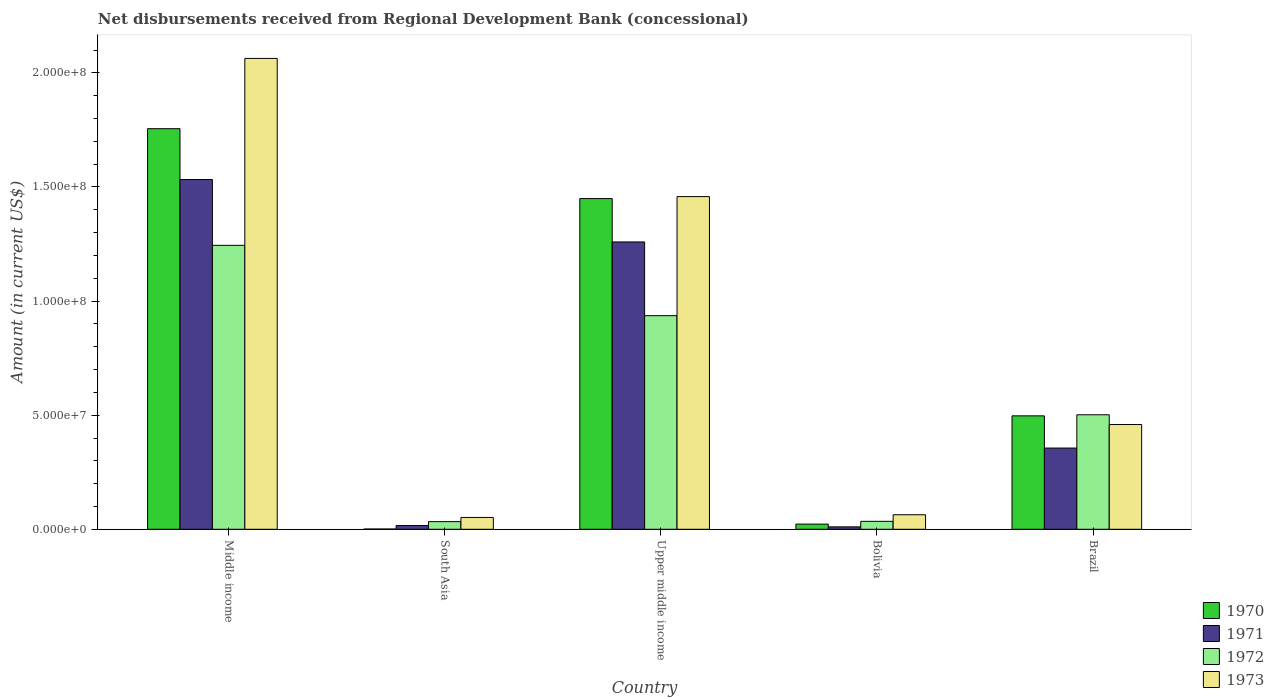How many different coloured bars are there?
Your answer should be very brief. 4. How many groups of bars are there?
Provide a short and direct response. 5. Are the number of bars per tick equal to the number of legend labels?
Offer a terse response. Yes. How many bars are there on the 4th tick from the right?
Your answer should be compact. 4. What is the label of the 5th group of bars from the left?
Provide a succinct answer. Brazil. In how many cases, is the number of bars for a given country not equal to the number of legend labels?
Offer a very short reply. 0. What is the amount of disbursements received from Regional Development Bank in 1973 in Brazil?
Give a very brief answer. 4.59e+07. Across all countries, what is the maximum amount of disbursements received from Regional Development Bank in 1973?
Ensure brevity in your answer.  2.06e+08. Across all countries, what is the minimum amount of disbursements received from Regional Development Bank in 1973?
Your answer should be very brief. 5.18e+06. In which country was the amount of disbursements received from Regional Development Bank in 1970 maximum?
Your answer should be very brief. Middle income. What is the total amount of disbursements received from Regional Development Bank in 1970 in the graph?
Your response must be concise. 3.73e+08. What is the difference between the amount of disbursements received from Regional Development Bank in 1971 in Bolivia and that in Brazil?
Provide a succinct answer. -3.45e+07. What is the difference between the amount of disbursements received from Regional Development Bank in 1973 in Middle income and the amount of disbursements received from Regional Development Bank in 1971 in Bolivia?
Your response must be concise. 2.05e+08. What is the average amount of disbursements received from Regional Development Bank in 1972 per country?
Offer a terse response. 5.50e+07. What is the difference between the amount of disbursements received from Regional Development Bank of/in 1973 and amount of disbursements received from Regional Development Bank of/in 1970 in South Asia?
Keep it short and to the point. 5.08e+06. What is the ratio of the amount of disbursements received from Regional Development Bank in 1973 in Brazil to that in Middle income?
Provide a succinct answer. 0.22. Is the amount of disbursements received from Regional Development Bank in 1973 in Brazil less than that in South Asia?
Offer a very short reply. No. Is the difference between the amount of disbursements received from Regional Development Bank in 1973 in South Asia and Upper middle income greater than the difference between the amount of disbursements received from Regional Development Bank in 1970 in South Asia and Upper middle income?
Offer a very short reply. Yes. What is the difference between the highest and the second highest amount of disbursements received from Regional Development Bank in 1971?
Provide a short and direct response. 1.18e+08. What is the difference between the highest and the lowest amount of disbursements received from Regional Development Bank in 1971?
Ensure brevity in your answer.  1.52e+08. In how many countries, is the amount of disbursements received from Regional Development Bank in 1972 greater than the average amount of disbursements received from Regional Development Bank in 1972 taken over all countries?
Provide a succinct answer. 2. Is the sum of the amount of disbursements received from Regional Development Bank in 1970 in Bolivia and Middle income greater than the maximum amount of disbursements received from Regional Development Bank in 1973 across all countries?
Provide a short and direct response. No. Is it the case that in every country, the sum of the amount of disbursements received from Regional Development Bank in 1973 and amount of disbursements received from Regional Development Bank in 1972 is greater than the sum of amount of disbursements received from Regional Development Bank in 1970 and amount of disbursements received from Regional Development Bank in 1971?
Provide a succinct answer. No. What does the 2nd bar from the right in Bolivia represents?
Give a very brief answer. 1972. Is it the case that in every country, the sum of the amount of disbursements received from Regional Development Bank in 1971 and amount of disbursements received from Regional Development Bank in 1972 is greater than the amount of disbursements received from Regional Development Bank in 1973?
Give a very brief answer. No. How many bars are there?
Provide a succinct answer. 20. Are all the bars in the graph horizontal?
Provide a succinct answer. No. What is the difference between two consecutive major ticks on the Y-axis?
Offer a terse response. 5.00e+07. Are the values on the major ticks of Y-axis written in scientific E-notation?
Provide a short and direct response. Yes. Does the graph contain grids?
Your response must be concise. No. How many legend labels are there?
Make the answer very short. 4. What is the title of the graph?
Your answer should be compact. Net disbursements received from Regional Development Bank (concessional). Does "1982" appear as one of the legend labels in the graph?
Your response must be concise. No. What is the label or title of the Y-axis?
Give a very brief answer. Amount (in current US$). What is the Amount (in current US$) of 1970 in Middle income?
Offer a very short reply. 1.76e+08. What is the Amount (in current US$) of 1971 in Middle income?
Offer a terse response. 1.53e+08. What is the Amount (in current US$) in 1972 in Middle income?
Provide a succinct answer. 1.24e+08. What is the Amount (in current US$) in 1973 in Middle income?
Give a very brief answer. 2.06e+08. What is the Amount (in current US$) in 1970 in South Asia?
Ensure brevity in your answer.  1.09e+05. What is the Amount (in current US$) of 1971 in South Asia?
Give a very brief answer. 1.65e+06. What is the Amount (in current US$) in 1972 in South Asia?
Offer a terse response. 3.35e+06. What is the Amount (in current US$) of 1973 in South Asia?
Offer a very short reply. 5.18e+06. What is the Amount (in current US$) of 1970 in Upper middle income?
Provide a succinct answer. 1.45e+08. What is the Amount (in current US$) of 1971 in Upper middle income?
Offer a very short reply. 1.26e+08. What is the Amount (in current US$) of 1972 in Upper middle income?
Offer a terse response. 9.36e+07. What is the Amount (in current US$) in 1973 in Upper middle income?
Ensure brevity in your answer.  1.46e+08. What is the Amount (in current US$) of 1970 in Bolivia?
Keep it short and to the point. 2.27e+06. What is the Amount (in current US$) in 1971 in Bolivia?
Ensure brevity in your answer.  1.06e+06. What is the Amount (in current US$) of 1972 in Bolivia?
Keep it short and to the point. 3.48e+06. What is the Amount (in current US$) of 1973 in Bolivia?
Your response must be concise. 6.36e+06. What is the Amount (in current US$) of 1970 in Brazil?
Ensure brevity in your answer.  4.97e+07. What is the Amount (in current US$) in 1971 in Brazil?
Your response must be concise. 3.56e+07. What is the Amount (in current US$) in 1972 in Brazil?
Offer a very short reply. 5.02e+07. What is the Amount (in current US$) of 1973 in Brazil?
Your response must be concise. 4.59e+07. Across all countries, what is the maximum Amount (in current US$) of 1970?
Offer a very short reply. 1.76e+08. Across all countries, what is the maximum Amount (in current US$) of 1971?
Offer a very short reply. 1.53e+08. Across all countries, what is the maximum Amount (in current US$) of 1972?
Your answer should be very brief. 1.24e+08. Across all countries, what is the maximum Amount (in current US$) in 1973?
Offer a terse response. 2.06e+08. Across all countries, what is the minimum Amount (in current US$) of 1970?
Provide a short and direct response. 1.09e+05. Across all countries, what is the minimum Amount (in current US$) of 1971?
Provide a short and direct response. 1.06e+06. Across all countries, what is the minimum Amount (in current US$) in 1972?
Provide a short and direct response. 3.35e+06. Across all countries, what is the minimum Amount (in current US$) of 1973?
Provide a succinct answer. 5.18e+06. What is the total Amount (in current US$) of 1970 in the graph?
Provide a short and direct response. 3.73e+08. What is the total Amount (in current US$) in 1971 in the graph?
Your answer should be very brief. 3.17e+08. What is the total Amount (in current US$) of 1972 in the graph?
Keep it short and to the point. 2.75e+08. What is the total Amount (in current US$) of 1973 in the graph?
Give a very brief answer. 4.10e+08. What is the difference between the Amount (in current US$) of 1970 in Middle income and that in South Asia?
Your answer should be very brief. 1.75e+08. What is the difference between the Amount (in current US$) in 1971 in Middle income and that in South Asia?
Offer a terse response. 1.52e+08. What is the difference between the Amount (in current US$) of 1972 in Middle income and that in South Asia?
Your answer should be compact. 1.21e+08. What is the difference between the Amount (in current US$) in 1973 in Middle income and that in South Asia?
Ensure brevity in your answer.  2.01e+08. What is the difference between the Amount (in current US$) of 1970 in Middle income and that in Upper middle income?
Offer a very short reply. 3.06e+07. What is the difference between the Amount (in current US$) in 1971 in Middle income and that in Upper middle income?
Your response must be concise. 2.74e+07. What is the difference between the Amount (in current US$) in 1972 in Middle income and that in Upper middle income?
Your answer should be very brief. 3.08e+07. What is the difference between the Amount (in current US$) of 1973 in Middle income and that in Upper middle income?
Offer a very short reply. 6.06e+07. What is the difference between the Amount (in current US$) in 1970 in Middle income and that in Bolivia?
Your answer should be very brief. 1.73e+08. What is the difference between the Amount (in current US$) of 1971 in Middle income and that in Bolivia?
Offer a very short reply. 1.52e+08. What is the difference between the Amount (in current US$) in 1972 in Middle income and that in Bolivia?
Make the answer very short. 1.21e+08. What is the difference between the Amount (in current US$) in 1973 in Middle income and that in Bolivia?
Your answer should be compact. 2.00e+08. What is the difference between the Amount (in current US$) of 1970 in Middle income and that in Brazil?
Your answer should be very brief. 1.26e+08. What is the difference between the Amount (in current US$) of 1971 in Middle income and that in Brazil?
Ensure brevity in your answer.  1.18e+08. What is the difference between the Amount (in current US$) of 1972 in Middle income and that in Brazil?
Provide a short and direct response. 7.43e+07. What is the difference between the Amount (in current US$) in 1973 in Middle income and that in Brazil?
Offer a very short reply. 1.60e+08. What is the difference between the Amount (in current US$) of 1970 in South Asia and that in Upper middle income?
Ensure brevity in your answer.  -1.45e+08. What is the difference between the Amount (in current US$) of 1971 in South Asia and that in Upper middle income?
Give a very brief answer. -1.24e+08. What is the difference between the Amount (in current US$) of 1972 in South Asia and that in Upper middle income?
Provide a short and direct response. -9.03e+07. What is the difference between the Amount (in current US$) of 1973 in South Asia and that in Upper middle income?
Your answer should be compact. -1.41e+08. What is the difference between the Amount (in current US$) in 1970 in South Asia and that in Bolivia?
Your answer should be very brief. -2.16e+06. What is the difference between the Amount (in current US$) of 1971 in South Asia and that in Bolivia?
Provide a succinct answer. 5.92e+05. What is the difference between the Amount (in current US$) of 1972 in South Asia and that in Bolivia?
Make the answer very short. -1.30e+05. What is the difference between the Amount (in current US$) in 1973 in South Asia and that in Bolivia?
Ensure brevity in your answer.  -1.18e+06. What is the difference between the Amount (in current US$) in 1970 in South Asia and that in Brazil?
Provide a succinct answer. -4.96e+07. What is the difference between the Amount (in current US$) of 1971 in South Asia and that in Brazil?
Offer a very short reply. -3.39e+07. What is the difference between the Amount (in current US$) of 1972 in South Asia and that in Brazil?
Your response must be concise. -4.68e+07. What is the difference between the Amount (in current US$) in 1973 in South Asia and that in Brazil?
Your response must be concise. -4.07e+07. What is the difference between the Amount (in current US$) in 1970 in Upper middle income and that in Bolivia?
Keep it short and to the point. 1.43e+08. What is the difference between the Amount (in current US$) of 1971 in Upper middle income and that in Bolivia?
Your answer should be very brief. 1.25e+08. What is the difference between the Amount (in current US$) of 1972 in Upper middle income and that in Bolivia?
Offer a very short reply. 9.01e+07. What is the difference between the Amount (in current US$) in 1973 in Upper middle income and that in Bolivia?
Your answer should be compact. 1.39e+08. What is the difference between the Amount (in current US$) in 1970 in Upper middle income and that in Brazil?
Ensure brevity in your answer.  9.52e+07. What is the difference between the Amount (in current US$) of 1971 in Upper middle income and that in Brazil?
Give a very brief answer. 9.03e+07. What is the difference between the Amount (in current US$) of 1972 in Upper middle income and that in Brazil?
Make the answer very short. 4.34e+07. What is the difference between the Amount (in current US$) in 1973 in Upper middle income and that in Brazil?
Offer a terse response. 9.99e+07. What is the difference between the Amount (in current US$) in 1970 in Bolivia and that in Brazil?
Your answer should be compact. -4.74e+07. What is the difference between the Amount (in current US$) in 1971 in Bolivia and that in Brazil?
Offer a very short reply. -3.45e+07. What is the difference between the Amount (in current US$) of 1972 in Bolivia and that in Brazil?
Keep it short and to the point. -4.67e+07. What is the difference between the Amount (in current US$) of 1973 in Bolivia and that in Brazil?
Ensure brevity in your answer.  -3.95e+07. What is the difference between the Amount (in current US$) in 1970 in Middle income and the Amount (in current US$) in 1971 in South Asia?
Provide a succinct answer. 1.74e+08. What is the difference between the Amount (in current US$) in 1970 in Middle income and the Amount (in current US$) in 1972 in South Asia?
Your answer should be very brief. 1.72e+08. What is the difference between the Amount (in current US$) in 1970 in Middle income and the Amount (in current US$) in 1973 in South Asia?
Keep it short and to the point. 1.70e+08. What is the difference between the Amount (in current US$) in 1971 in Middle income and the Amount (in current US$) in 1972 in South Asia?
Your answer should be compact. 1.50e+08. What is the difference between the Amount (in current US$) of 1971 in Middle income and the Amount (in current US$) of 1973 in South Asia?
Offer a very short reply. 1.48e+08. What is the difference between the Amount (in current US$) of 1972 in Middle income and the Amount (in current US$) of 1973 in South Asia?
Provide a short and direct response. 1.19e+08. What is the difference between the Amount (in current US$) in 1970 in Middle income and the Amount (in current US$) in 1971 in Upper middle income?
Offer a terse response. 4.96e+07. What is the difference between the Amount (in current US$) in 1970 in Middle income and the Amount (in current US$) in 1972 in Upper middle income?
Keep it short and to the point. 8.19e+07. What is the difference between the Amount (in current US$) of 1970 in Middle income and the Amount (in current US$) of 1973 in Upper middle income?
Offer a very short reply. 2.98e+07. What is the difference between the Amount (in current US$) of 1971 in Middle income and the Amount (in current US$) of 1972 in Upper middle income?
Ensure brevity in your answer.  5.97e+07. What is the difference between the Amount (in current US$) in 1971 in Middle income and the Amount (in current US$) in 1973 in Upper middle income?
Give a very brief answer. 7.49e+06. What is the difference between the Amount (in current US$) in 1972 in Middle income and the Amount (in current US$) in 1973 in Upper middle income?
Provide a short and direct response. -2.14e+07. What is the difference between the Amount (in current US$) of 1970 in Middle income and the Amount (in current US$) of 1971 in Bolivia?
Provide a short and direct response. 1.74e+08. What is the difference between the Amount (in current US$) of 1970 in Middle income and the Amount (in current US$) of 1972 in Bolivia?
Provide a short and direct response. 1.72e+08. What is the difference between the Amount (in current US$) in 1970 in Middle income and the Amount (in current US$) in 1973 in Bolivia?
Ensure brevity in your answer.  1.69e+08. What is the difference between the Amount (in current US$) of 1971 in Middle income and the Amount (in current US$) of 1972 in Bolivia?
Provide a short and direct response. 1.50e+08. What is the difference between the Amount (in current US$) of 1971 in Middle income and the Amount (in current US$) of 1973 in Bolivia?
Provide a succinct answer. 1.47e+08. What is the difference between the Amount (in current US$) of 1972 in Middle income and the Amount (in current US$) of 1973 in Bolivia?
Provide a succinct answer. 1.18e+08. What is the difference between the Amount (in current US$) of 1970 in Middle income and the Amount (in current US$) of 1971 in Brazil?
Provide a short and direct response. 1.40e+08. What is the difference between the Amount (in current US$) of 1970 in Middle income and the Amount (in current US$) of 1972 in Brazil?
Keep it short and to the point. 1.25e+08. What is the difference between the Amount (in current US$) of 1970 in Middle income and the Amount (in current US$) of 1973 in Brazil?
Make the answer very short. 1.30e+08. What is the difference between the Amount (in current US$) in 1971 in Middle income and the Amount (in current US$) in 1972 in Brazil?
Offer a very short reply. 1.03e+08. What is the difference between the Amount (in current US$) in 1971 in Middle income and the Amount (in current US$) in 1973 in Brazil?
Ensure brevity in your answer.  1.07e+08. What is the difference between the Amount (in current US$) in 1972 in Middle income and the Amount (in current US$) in 1973 in Brazil?
Your response must be concise. 7.85e+07. What is the difference between the Amount (in current US$) in 1970 in South Asia and the Amount (in current US$) in 1971 in Upper middle income?
Your answer should be very brief. -1.26e+08. What is the difference between the Amount (in current US$) of 1970 in South Asia and the Amount (in current US$) of 1972 in Upper middle income?
Your answer should be very brief. -9.35e+07. What is the difference between the Amount (in current US$) in 1970 in South Asia and the Amount (in current US$) in 1973 in Upper middle income?
Your answer should be very brief. -1.46e+08. What is the difference between the Amount (in current US$) of 1971 in South Asia and the Amount (in current US$) of 1972 in Upper middle income?
Keep it short and to the point. -9.20e+07. What is the difference between the Amount (in current US$) of 1971 in South Asia and the Amount (in current US$) of 1973 in Upper middle income?
Your answer should be very brief. -1.44e+08. What is the difference between the Amount (in current US$) in 1972 in South Asia and the Amount (in current US$) in 1973 in Upper middle income?
Provide a short and direct response. -1.42e+08. What is the difference between the Amount (in current US$) in 1970 in South Asia and the Amount (in current US$) in 1971 in Bolivia?
Offer a terse response. -9.49e+05. What is the difference between the Amount (in current US$) of 1970 in South Asia and the Amount (in current US$) of 1972 in Bolivia?
Ensure brevity in your answer.  -3.37e+06. What is the difference between the Amount (in current US$) in 1970 in South Asia and the Amount (in current US$) in 1973 in Bolivia?
Ensure brevity in your answer.  -6.25e+06. What is the difference between the Amount (in current US$) of 1971 in South Asia and the Amount (in current US$) of 1972 in Bolivia?
Offer a terse response. -1.83e+06. What is the difference between the Amount (in current US$) of 1971 in South Asia and the Amount (in current US$) of 1973 in Bolivia?
Provide a short and direct response. -4.71e+06. What is the difference between the Amount (in current US$) of 1972 in South Asia and the Amount (in current US$) of 1973 in Bolivia?
Keep it short and to the point. -3.01e+06. What is the difference between the Amount (in current US$) of 1970 in South Asia and the Amount (in current US$) of 1971 in Brazil?
Provide a succinct answer. -3.55e+07. What is the difference between the Amount (in current US$) of 1970 in South Asia and the Amount (in current US$) of 1972 in Brazil?
Your answer should be compact. -5.01e+07. What is the difference between the Amount (in current US$) of 1970 in South Asia and the Amount (in current US$) of 1973 in Brazil?
Your response must be concise. -4.58e+07. What is the difference between the Amount (in current US$) of 1971 in South Asia and the Amount (in current US$) of 1972 in Brazil?
Your response must be concise. -4.85e+07. What is the difference between the Amount (in current US$) in 1971 in South Asia and the Amount (in current US$) in 1973 in Brazil?
Your answer should be compact. -4.43e+07. What is the difference between the Amount (in current US$) in 1972 in South Asia and the Amount (in current US$) in 1973 in Brazil?
Give a very brief answer. -4.26e+07. What is the difference between the Amount (in current US$) in 1970 in Upper middle income and the Amount (in current US$) in 1971 in Bolivia?
Provide a succinct answer. 1.44e+08. What is the difference between the Amount (in current US$) in 1970 in Upper middle income and the Amount (in current US$) in 1972 in Bolivia?
Your answer should be compact. 1.41e+08. What is the difference between the Amount (in current US$) in 1970 in Upper middle income and the Amount (in current US$) in 1973 in Bolivia?
Offer a very short reply. 1.39e+08. What is the difference between the Amount (in current US$) in 1971 in Upper middle income and the Amount (in current US$) in 1972 in Bolivia?
Provide a short and direct response. 1.22e+08. What is the difference between the Amount (in current US$) of 1971 in Upper middle income and the Amount (in current US$) of 1973 in Bolivia?
Provide a short and direct response. 1.20e+08. What is the difference between the Amount (in current US$) in 1972 in Upper middle income and the Amount (in current US$) in 1973 in Bolivia?
Ensure brevity in your answer.  8.72e+07. What is the difference between the Amount (in current US$) of 1970 in Upper middle income and the Amount (in current US$) of 1971 in Brazil?
Provide a succinct answer. 1.09e+08. What is the difference between the Amount (in current US$) of 1970 in Upper middle income and the Amount (in current US$) of 1972 in Brazil?
Provide a short and direct response. 9.48e+07. What is the difference between the Amount (in current US$) of 1970 in Upper middle income and the Amount (in current US$) of 1973 in Brazil?
Your response must be concise. 9.90e+07. What is the difference between the Amount (in current US$) in 1971 in Upper middle income and the Amount (in current US$) in 1972 in Brazil?
Your answer should be very brief. 7.57e+07. What is the difference between the Amount (in current US$) of 1971 in Upper middle income and the Amount (in current US$) of 1973 in Brazil?
Give a very brief answer. 8.00e+07. What is the difference between the Amount (in current US$) in 1972 in Upper middle income and the Amount (in current US$) in 1973 in Brazil?
Ensure brevity in your answer.  4.77e+07. What is the difference between the Amount (in current US$) in 1970 in Bolivia and the Amount (in current US$) in 1971 in Brazil?
Provide a succinct answer. -3.33e+07. What is the difference between the Amount (in current US$) of 1970 in Bolivia and the Amount (in current US$) of 1972 in Brazil?
Offer a terse response. -4.79e+07. What is the difference between the Amount (in current US$) of 1970 in Bolivia and the Amount (in current US$) of 1973 in Brazil?
Keep it short and to the point. -4.36e+07. What is the difference between the Amount (in current US$) of 1971 in Bolivia and the Amount (in current US$) of 1972 in Brazil?
Provide a succinct answer. -4.91e+07. What is the difference between the Amount (in current US$) of 1971 in Bolivia and the Amount (in current US$) of 1973 in Brazil?
Offer a very short reply. -4.49e+07. What is the difference between the Amount (in current US$) of 1972 in Bolivia and the Amount (in current US$) of 1973 in Brazil?
Your response must be concise. -4.24e+07. What is the average Amount (in current US$) in 1970 per country?
Offer a very short reply. 7.45e+07. What is the average Amount (in current US$) of 1971 per country?
Ensure brevity in your answer.  6.35e+07. What is the average Amount (in current US$) in 1972 per country?
Your answer should be very brief. 5.50e+07. What is the average Amount (in current US$) of 1973 per country?
Your response must be concise. 8.19e+07. What is the difference between the Amount (in current US$) of 1970 and Amount (in current US$) of 1971 in Middle income?
Provide a succinct answer. 2.23e+07. What is the difference between the Amount (in current US$) of 1970 and Amount (in current US$) of 1972 in Middle income?
Provide a short and direct response. 5.11e+07. What is the difference between the Amount (in current US$) in 1970 and Amount (in current US$) in 1973 in Middle income?
Give a very brief answer. -3.08e+07. What is the difference between the Amount (in current US$) of 1971 and Amount (in current US$) of 1972 in Middle income?
Your answer should be compact. 2.88e+07. What is the difference between the Amount (in current US$) in 1971 and Amount (in current US$) in 1973 in Middle income?
Provide a succinct answer. -5.31e+07. What is the difference between the Amount (in current US$) in 1972 and Amount (in current US$) in 1973 in Middle income?
Your answer should be very brief. -8.19e+07. What is the difference between the Amount (in current US$) of 1970 and Amount (in current US$) of 1971 in South Asia?
Your answer should be very brief. -1.54e+06. What is the difference between the Amount (in current US$) in 1970 and Amount (in current US$) in 1972 in South Asia?
Keep it short and to the point. -3.24e+06. What is the difference between the Amount (in current US$) of 1970 and Amount (in current US$) of 1973 in South Asia?
Your answer should be compact. -5.08e+06. What is the difference between the Amount (in current US$) in 1971 and Amount (in current US$) in 1972 in South Asia?
Your answer should be very brief. -1.70e+06. What is the difference between the Amount (in current US$) of 1971 and Amount (in current US$) of 1973 in South Asia?
Provide a short and direct response. -3.53e+06. What is the difference between the Amount (in current US$) in 1972 and Amount (in current US$) in 1973 in South Asia?
Your answer should be compact. -1.83e+06. What is the difference between the Amount (in current US$) in 1970 and Amount (in current US$) in 1971 in Upper middle income?
Provide a succinct answer. 1.90e+07. What is the difference between the Amount (in current US$) of 1970 and Amount (in current US$) of 1972 in Upper middle income?
Offer a terse response. 5.13e+07. What is the difference between the Amount (in current US$) of 1970 and Amount (in current US$) of 1973 in Upper middle income?
Make the answer very short. -8.58e+05. What is the difference between the Amount (in current US$) in 1971 and Amount (in current US$) in 1972 in Upper middle income?
Offer a terse response. 3.23e+07. What is the difference between the Amount (in current US$) in 1971 and Amount (in current US$) in 1973 in Upper middle income?
Give a very brief answer. -1.99e+07. What is the difference between the Amount (in current US$) of 1972 and Amount (in current US$) of 1973 in Upper middle income?
Ensure brevity in your answer.  -5.22e+07. What is the difference between the Amount (in current US$) of 1970 and Amount (in current US$) of 1971 in Bolivia?
Provide a short and direct response. 1.21e+06. What is the difference between the Amount (in current US$) in 1970 and Amount (in current US$) in 1972 in Bolivia?
Give a very brief answer. -1.21e+06. What is the difference between the Amount (in current US$) in 1970 and Amount (in current US$) in 1973 in Bolivia?
Provide a succinct answer. -4.09e+06. What is the difference between the Amount (in current US$) of 1971 and Amount (in current US$) of 1972 in Bolivia?
Offer a very short reply. -2.42e+06. What is the difference between the Amount (in current US$) in 1971 and Amount (in current US$) in 1973 in Bolivia?
Provide a succinct answer. -5.30e+06. What is the difference between the Amount (in current US$) in 1972 and Amount (in current US$) in 1973 in Bolivia?
Give a very brief answer. -2.88e+06. What is the difference between the Amount (in current US$) of 1970 and Amount (in current US$) of 1971 in Brazil?
Offer a terse response. 1.41e+07. What is the difference between the Amount (in current US$) of 1970 and Amount (in current US$) of 1972 in Brazil?
Ensure brevity in your answer.  -4.68e+05. What is the difference between the Amount (in current US$) in 1970 and Amount (in current US$) in 1973 in Brazil?
Provide a succinct answer. 3.80e+06. What is the difference between the Amount (in current US$) of 1971 and Amount (in current US$) of 1972 in Brazil?
Give a very brief answer. -1.46e+07. What is the difference between the Amount (in current US$) of 1971 and Amount (in current US$) of 1973 in Brazil?
Ensure brevity in your answer.  -1.03e+07. What is the difference between the Amount (in current US$) in 1972 and Amount (in current US$) in 1973 in Brazil?
Offer a very short reply. 4.27e+06. What is the ratio of the Amount (in current US$) in 1970 in Middle income to that in South Asia?
Provide a short and direct response. 1610.58. What is the ratio of the Amount (in current US$) in 1971 in Middle income to that in South Asia?
Your answer should be compact. 92.89. What is the ratio of the Amount (in current US$) of 1972 in Middle income to that in South Asia?
Your response must be concise. 37.14. What is the ratio of the Amount (in current US$) in 1973 in Middle income to that in South Asia?
Provide a succinct answer. 39.8. What is the ratio of the Amount (in current US$) of 1970 in Middle income to that in Upper middle income?
Your answer should be compact. 1.21. What is the ratio of the Amount (in current US$) in 1971 in Middle income to that in Upper middle income?
Your response must be concise. 1.22. What is the ratio of the Amount (in current US$) in 1972 in Middle income to that in Upper middle income?
Make the answer very short. 1.33. What is the ratio of the Amount (in current US$) of 1973 in Middle income to that in Upper middle income?
Your answer should be very brief. 1.42. What is the ratio of the Amount (in current US$) of 1970 in Middle income to that in Bolivia?
Ensure brevity in your answer.  77.34. What is the ratio of the Amount (in current US$) in 1971 in Middle income to that in Bolivia?
Your answer should be very brief. 144.87. What is the ratio of the Amount (in current US$) in 1972 in Middle income to that in Bolivia?
Your answer should be compact. 35.76. What is the ratio of the Amount (in current US$) in 1973 in Middle income to that in Bolivia?
Your answer should be very brief. 32.44. What is the ratio of the Amount (in current US$) of 1970 in Middle income to that in Brazil?
Give a very brief answer. 3.53. What is the ratio of the Amount (in current US$) in 1971 in Middle income to that in Brazil?
Keep it short and to the point. 4.31. What is the ratio of the Amount (in current US$) in 1972 in Middle income to that in Brazil?
Provide a short and direct response. 2.48. What is the ratio of the Amount (in current US$) in 1973 in Middle income to that in Brazil?
Your response must be concise. 4.49. What is the ratio of the Amount (in current US$) in 1970 in South Asia to that in Upper middle income?
Give a very brief answer. 0. What is the ratio of the Amount (in current US$) of 1971 in South Asia to that in Upper middle income?
Make the answer very short. 0.01. What is the ratio of the Amount (in current US$) of 1972 in South Asia to that in Upper middle income?
Offer a very short reply. 0.04. What is the ratio of the Amount (in current US$) in 1973 in South Asia to that in Upper middle income?
Provide a succinct answer. 0.04. What is the ratio of the Amount (in current US$) in 1970 in South Asia to that in Bolivia?
Offer a terse response. 0.05. What is the ratio of the Amount (in current US$) of 1971 in South Asia to that in Bolivia?
Offer a terse response. 1.56. What is the ratio of the Amount (in current US$) in 1972 in South Asia to that in Bolivia?
Provide a short and direct response. 0.96. What is the ratio of the Amount (in current US$) in 1973 in South Asia to that in Bolivia?
Provide a succinct answer. 0.82. What is the ratio of the Amount (in current US$) in 1970 in South Asia to that in Brazil?
Give a very brief answer. 0. What is the ratio of the Amount (in current US$) of 1971 in South Asia to that in Brazil?
Your answer should be compact. 0.05. What is the ratio of the Amount (in current US$) of 1972 in South Asia to that in Brazil?
Give a very brief answer. 0.07. What is the ratio of the Amount (in current US$) in 1973 in South Asia to that in Brazil?
Keep it short and to the point. 0.11. What is the ratio of the Amount (in current US$) in 1970 in Upper middle income to that in Bolivia?
Your answer should be compact. 63.85. What is the ratio of the Amount (in current US$) of 1971 in Upper middle income to that in Bolivia?
Keep it short and to the point. 119.02. What is the ratio of the Amount (in current US$) of 1972 in Upper middle income to that in Bolivia?
Provide a succinct answer. 26.9. What is the ratio of the Amount (in current US$) in 1973 in Upper middle income to that in Bolivia?
Your answer should be compact. 22.92. What is the ratio of the Amount (in current US$) in 1970 in Upper middle income to that in Brazil?
Provide a short and direct response. 2.92. What is the ratio of the Amount (in current US$) in 1971 in Upper middle income to that in Brazil?
Keep it short and to the point. 3.54. What is the ratio of the Amount (in current US$) in 1972 in Upper middle income to that in Brazil?
Ensure brevity in your answer.  1.87. What is the ratio of the Amount (in current US$) of 1973 in Upper middle income to that in Brazil?
Ensure brevity in your answer.  3.18. What is the ratio of the Amount (in current US$) in 1970 in Bolivia to that in Brazil?
Make the answer very short. 0.05. What is the ratio of the Amount (in current US$) in 1971 in Bolivia to that in Brazil?
Offer a very short reply. 0.03. What is the ratio of the Amount (in current US$) of 1972 in Bolivia to that in Brazil?
Your response must be concise. 0.07. What is the ratio of the Amount (in current US$) of 1973 in Bolivia to that in Brazil?
Keep it short and to the point. 0.14. What is the difference between the highest and the second highest Amount (in current US$) in 1970?
Provide a succinct answer. 3.06e+07. What is the difference between the highest and the second highest Amount (in current US$) of 1971?
Your response must be concise. 2.74e+07. What is the difference between the highest and the second highest Amount (in current US$) in 1972?
Provide a short and direct response. 3.08e+07. What is the difference between the highest and the second highest Amount (in current US$) in 1973?
Provide a succinct answer. 6.06e+07. What is the difference between the highest and the lowest Amount (in current US$) in 1970?
Ensure brevity in your answer.  1.75e+08. What is the difference between the highest and the lowest Amount (in current US$) of 1971?
Your answer should be compact. 1.52e+08. What is the difference between the highest and the lowest Amount (in current US$) of 1972?
Give a very brief answer. 1.21e+08. What is the difference between the highest and the lowest Amount (in current US$) in 1973?
Offer a terse response. 2.01e+08. 